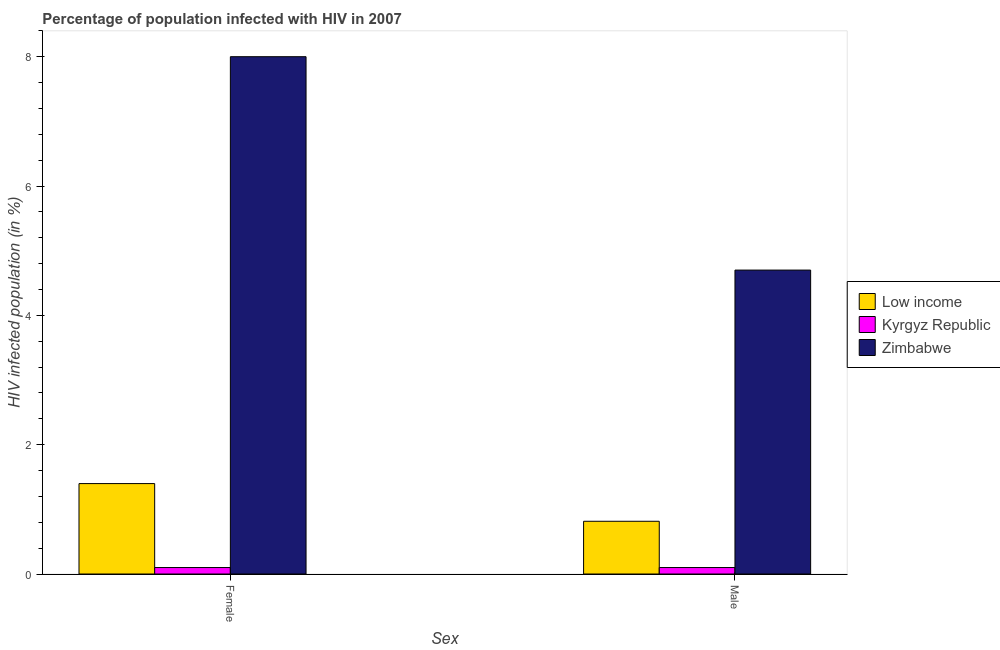How many different coloured bars are there?
Provide a succinct answer. 3. What is the percentage of males who are infected with hiv in Low income?
Provide a succinct answer. 0.82. Across all countries, what is the maximum percentage of males who are infected with hiv?
Ensure brevity in your answer.  4.7. Across all countries, what is the minimum percentage of females who are infected with hiv?
Provide a short and direct response. 0.1. In which country was the percentage of females who are infected with hiv maximum?
Your response must be concise. Zimbabwe. In which country was the percentage of males who are infected with hiv minimum?
Offer a very short reply. Kyrgyz Republic. What is the total percentage of females who are infected with hiv in the graph?
Offer a very short reply. 9.5. What is the difference between the percentage of females who are infected with hiv in Zimbabwe and that in Low income?
Your answer should be very brief. 6.6. What is the difference between the percentage of females who are infected with hiv in Kyrgyz Republic and the percentage of males who are infected with hiv in Low income?
Keep it short and to the point. -0.72. What is the average percentage of males who are infected with hiv per country?
Your answer should be compact. 1.87. What is the difference between the percentage of females who are infected with hiv and percentage of males who are infected with hiv in Low income?
Keep it short and to the point. 0.58. In how many countries, is the percentage of females who are infected with hiv greater than 4 %?
Your answer should be compact. 1. What is the ratio of the percentage of females who are infected with hiv in Kyrgyz Republic to that in Zimbabwe?
Provide a succinct answer. 0.01. Is the percentage of males who are infected with hiv in Zimbabwe less than that in Low income?
Offer a terse response. No. What does the 3rd bar from the left in Female represents?
Your answer should be compact. Zimbabwe. What does the 1st bar from the right in Female represents?
Provide a succinct answer. Zimbabwe. How many countries are there in the graph?
Give a very brief answer. 3. What is the difference between two consecutive major ticks on the Y-axis?
Keep it short and to the point. 2. Does the graph contain any zero values?
Give a very brief answer. No. How many legend labels are there?
Give a very brief answer. 3. What is the title of the graph?
Provide a short and direct response. Percentage of population infected with HIV in 2007. What is the label or title of the X-axis?
Your response must be concise. Sex. What is the label or title of the Y-axis?
Provide a succinct answer. HIV infected population (in %). What is the HIV infected population (in %) of Low income in Female?
Give a very brief answer. 1.4. What is the HIV infected population (in %) of Kyrgyz Republic in Female?
Offer a terse response. 0.1. What is the HIV infected population (in %) in Low income in Male?
Your answer should be very brief. 0.82. What is the HIV infected population (in %) in Kyrgyz Republic in Male?
Make the answer very short. 0.1. Across all Sex, what is the maximum HIV infected population (in %) in Low income?
Your answer should be compact. 1.4. Across all Sex, what is the minimum HIV infected population (in %) in Low income?
Provide a succinct answer. 0.82. What is the total HIV infected population (in %) of Low income in the graph?
Offer a very short reply. 2.21. What is the total HIV infected population (in %) in Zimbabwe in the graph?
Keep it short and to the point. 12.7. What is the difference between the HIV infected population (in %) of Low income in Female and that in Male?
Ensure brevity in your answer.  0.58. What is the difference between the HIV infected population (in %) in Kyrgyz Republic in Female and that in Male?
Provide a short and direct response. 0. What is the difference between the HIV infected population (in %) of Zimbabwe in Female and that in Male?
Provide a short and direct response. 3.3. What is the difference between the HIV infected population (in %) of Low income in Female and the HIV infected population (in %) of Kyrgyz Republic in Male?
Your answer should be compact. 1.3. What is the difference between the HIV infected population (in %) in Low income in Female and the HIV infected population (in %) in Zimbabwe in Male?
Offer a terse response. -3.3. What is the difference between the HIV infected population (in %) in Kyrgyz Republic in Female and the HIV infected population (in %) in Zimbabwe in Male?
Your response must be concise. -4.6. What is the average HIV infected population (in %) in Low income per Sex?
Offer a very short reply. 1.11. What is the average HIV infected population (in %) in Zimbabwe per Sex?
Your response must be concise. 6.35. What is the difference between the HIV infected population (in %) of Low income and HIV infected population (in %) of Kyrgyz Republic in Female?
Your answer should be compact. 1.3. What is the difference between the HIV infected population (in %) in Low income and HIV infected population (in %) in Zimbabwe in Female?
Provide a succinct answer. -6.6. What is the difference between the HIV infected population (in %) of Kyrgyz Republic and HIV infected population (in %) of Zimbabwe in Female?
Offer a terse response. -7.9. What is the difference between the HIV infected population (in %) in Low income and HIV infected population (in %) in Kyrgyz Republic in Male?
Provide a short and direct response. 0.72. What is the difference between the HIV infected population (in %) of Low income and HIV infected population (in %) of Zimbabwe in Male?
Offer a terse response. -3.88. What is the difference between the HIV infected population (in %) of Kyrgyz Republic and HIV infected population (in %) of Zimbabwe in Male?
Offer a very short reply. -4.6. What is the ratio of the HIV infected population (in %) in Low income in Female to that in Male?
Your response must be concise. 1.71. What is the ratio of the HIV infected population (in %) of Zimbabwe in Female to that in Male?
Ensure brevity in your answer.  1.7. What is the difference between the highest and the second highest HIV infected population (in %) of Low income?
Keep it short and to the point. 0.58. What is the difference between the highest and the second highest HIV infected population (in %) in Kyrgyz Republic?
Make the answer very short. 0. What is the difference between the highest and the lowest HIV infected population (in %) of Low income?
Offer a very short reply. 0.58. What is the difference between the highest and the lowest HIV infected population (in %) in Kyrgyz Republic?
Make the answer very short. 0. What is the difference between the highest and the lowest HIV infected population (in %) in Zimbabwe?
Your response must be concise. 3.3. 